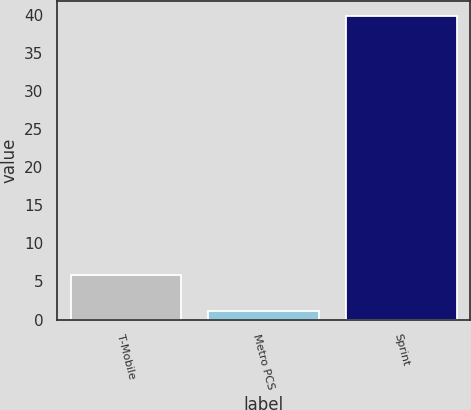Convert chart. <chart><loc_0><loc_0><loc_500><loc_500><bar_chart><fcel>T-Mobile<fcel>Metro PCS<fcel>Sprint<nl><fcel>5.8<fcel>1.1<fcel>39.8<nl></chart> 